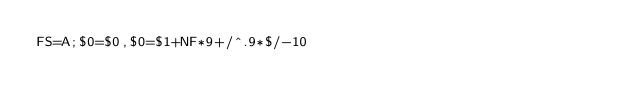Convert code to text. <code><loc_0><loc_0><loc_500><loc_500><_Awk_>FS=A;$0=$0,$0=$1+NF*9+/^.9*$/-10</code> 